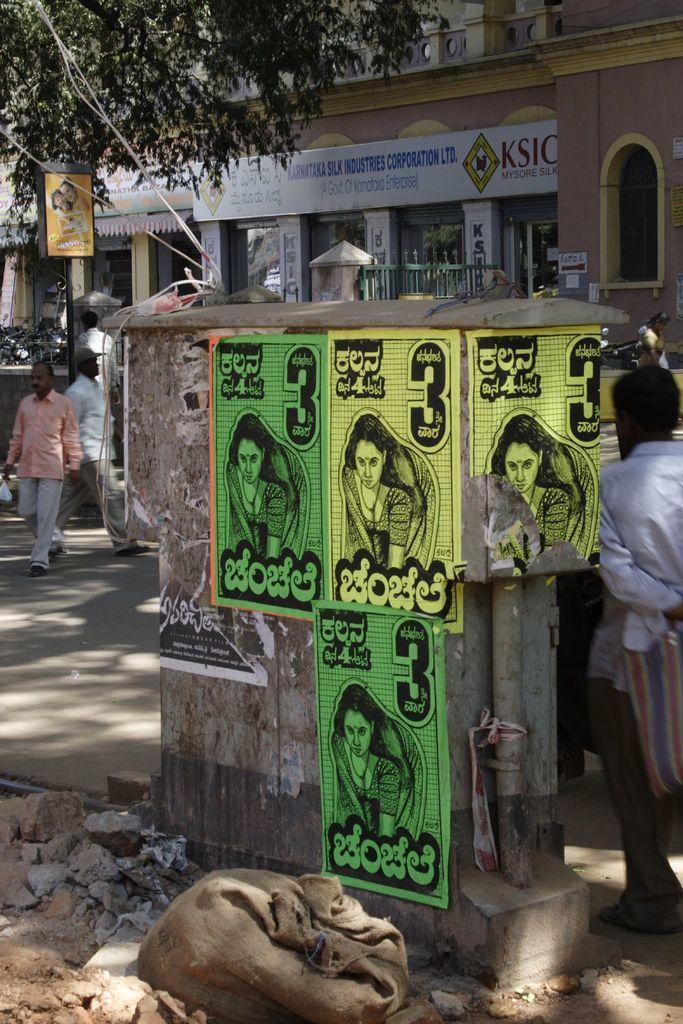In one or two sentences, can you explain what this image depicts? In this image I can see there is a building. In front of the building there are persons walking and holding an object. And there is a pole with the board. And at the side there are stones and a bag. And there is a wall with posters. 